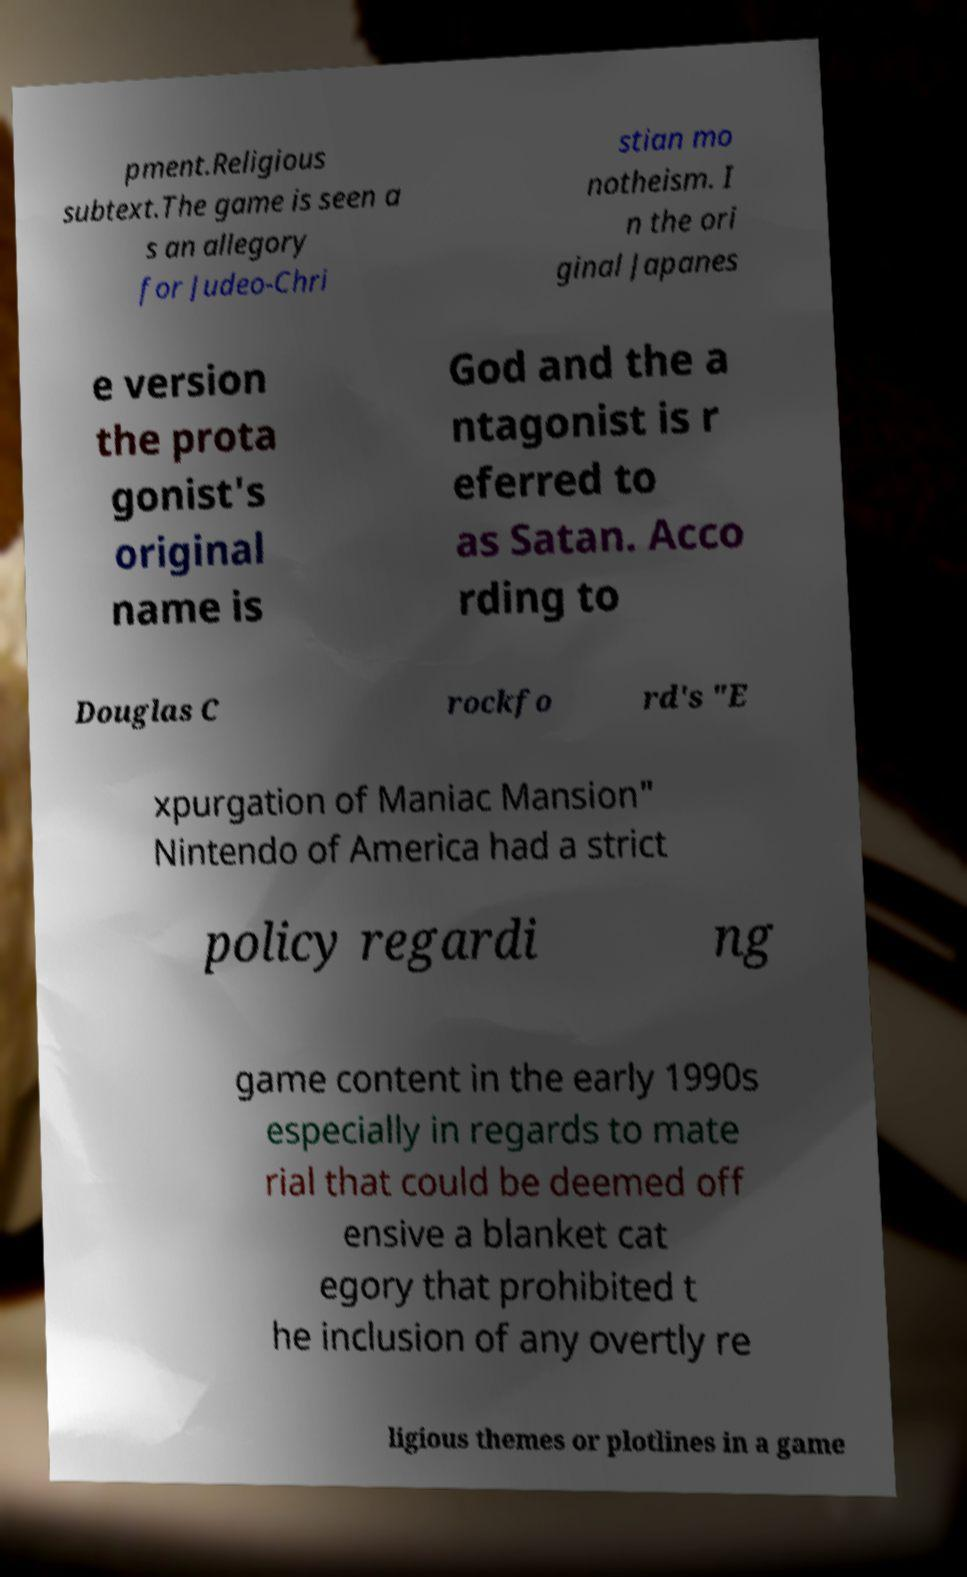Please identify and transcribe the text found in this image. pment.Religious subtext.The game is seen a s an allegory for Judeo-Chri stian mo notheism. I n the ori ginal Japanes e version the prota gonist's original name is God and the a ntagonist is r eferred to as Satan. Acco rding to Douglas C rockfo rd's "E xpurgation of Maniac Mansion" Nintendo of America had a strict policy regardi ng game content in the early 1990s especially in regards to mate rial that could be deemed off ensive a blanket cat egory that prohibited t he inclusion of any overtly re ligious themes or plotlines in a game 